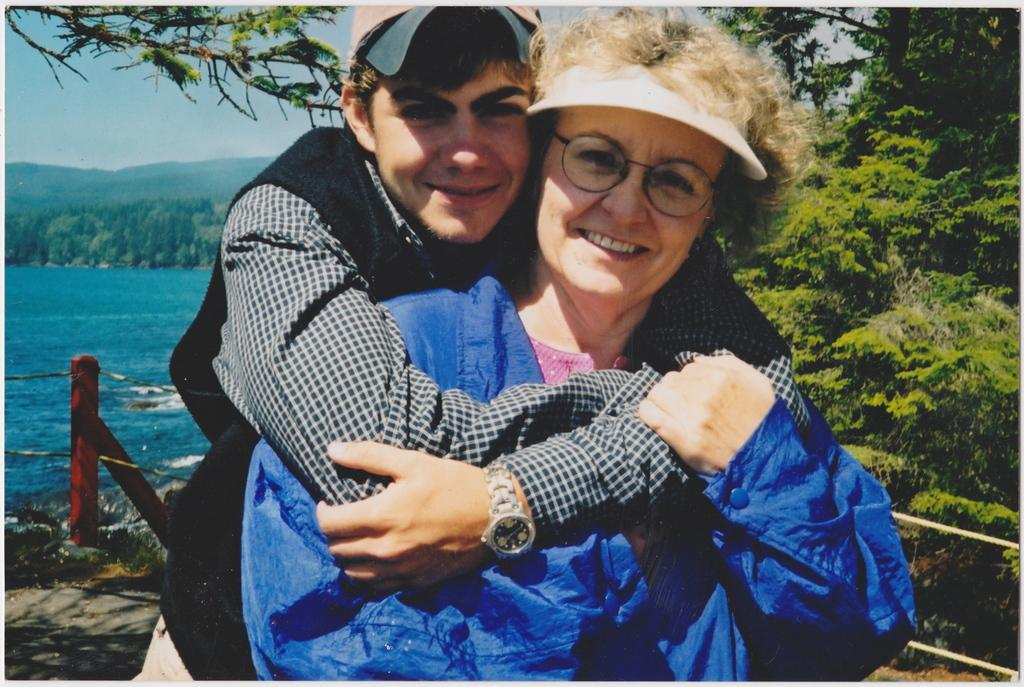What is happening between the man and the woman in the image? The man is holding the woman in the image. What can be seen in the background of the image? There is sky, hills, trees, water, a fence, and a road visible in the background of the image. Can you describe the natural environment in the image? The natural environment includes hills, trees, and water. What type of hammer is the giraffe using to fix the fence in the image? There is no giraffe or hammer present in the image. 